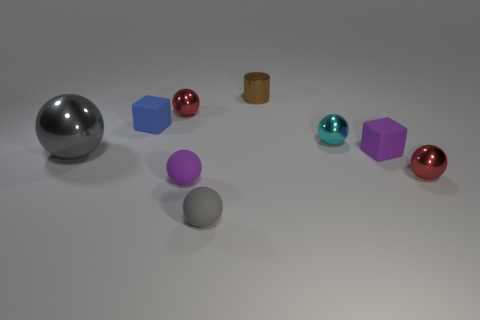How many cylinders are either gray matte objects or big red objects?
Ensure brevity in your answer.  0. Is the material of the tiny cyan thing the same as the brown thing?
Give a very brief answer. Yes. What number of other objects are there of the same color as the big metallic ball?
Your response must be concise. 1. The purple matte thing on the right side of the tiny metallic cylinder has what shape?
Your answer should be compact. Cube. What number of things are either big red cylinders or cyan metal spheres?
Provide a succinct answer. 1. There is a purple cube; is it the same size as the gray object to the right of the purple matte ball?
Ensure brevity in your answer.  Yes. What number of other objects are there of the same material as the purple cube?
Ensure brevity in your answer.  3. How many things are rubber objects that are in front of the tiny blue object or tiny red objects that are behind the cyan thing?
Offer a terse response. 4. There is another big object that is the same shape as the cyan object; what is it made of?
Provide a succinct answer. Metal. Is there a cyan thing?
Provide a succinct answer. Yes. 